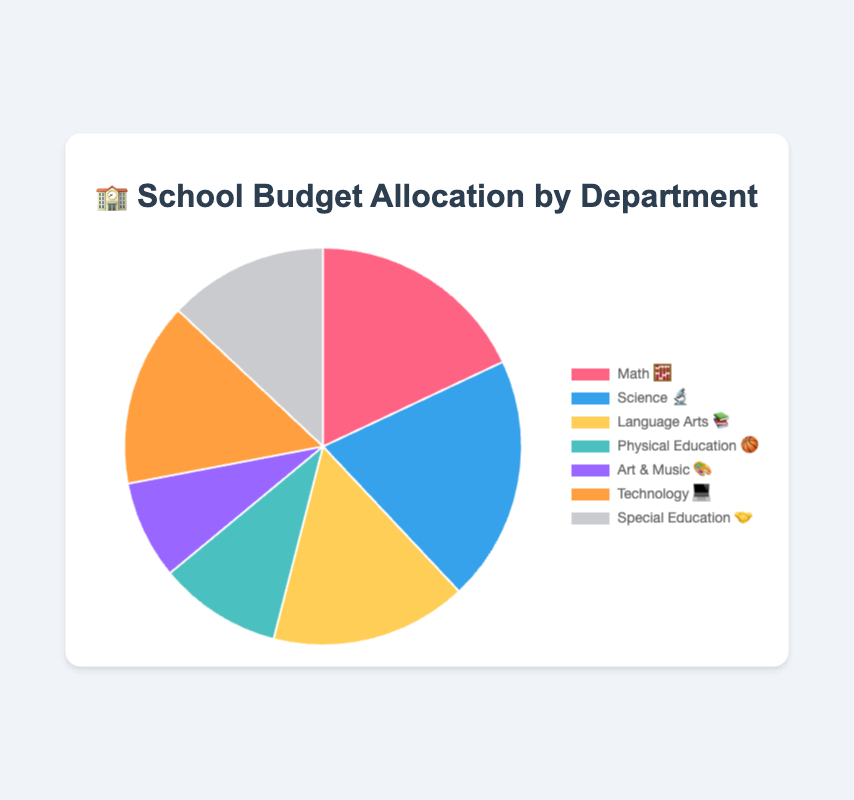What department has the largest budget allocation? The department with the highest budget percentage is the largest allocation. In the given data, Science (🔬) has the highest budget at 20%.
Answer: Science (🔬) What department has the smallest budget allocation? The department with the lowest budget percentage is the smallest allocation. In the given data, Art & Music (🎨) has the lowest budget at 8%.
Answer: Art & Music (🎨) How much more budget percentage does Science (🔬) get compared to Physical Education (🏀)? Subtract the budget percentage of Physical Education (10%) from that of Science (20%). The difference is 20% - 10% = 10%.
Answer: 10% What is the total budget percentage allocated to Math (🧮) and Technology (💻) combined? Add the budget percentages of Math (18%) and Technology (15%). The total is 18% + 15% = 33%.
Answer: 33% Which department has a budget contribution that is closest to the median budget allocation? First, sort the budget percentages: 8%, 10%, 13%, 15%, 16%, 18%, 20%. The median value is the fourth value in the sorted list, which is 15%, corresponding to Technology (💻).
Answer: Technology (💻) What is the difference in budget allocation between Language Arts (📚) and Special Education (🤝)? Subtract the budget percentage of Special Education (13%) from that of Language Arts (16%). The difference is 16% - 13% = 3%.
Answer: 3% How many departments have a budget allocation of 15% or higher? Identify the departments with budget percentages ≥ 15%. These are Math (18%), Science (20%), Language Arts (16%), and Technology (15%). There are 4 such departments.
Answer: 4 What is the average budget allocation across all departments? Add all budget percentages and divide by the total number of departments. The total sum is 18% + 20% + 16% + 10% + 8% + 15% + 13% = 100%. There are 7 departments, so the average is 100% / 7 ≈ 14.29%.
Answer: ~14.29% If the Technology (💻) budget was increased by 5%, how would this impact the budget compared to Science (🔬)? Adding 5% to Technology's budget increases it from 15% to 20%. This makes it equal to Science's budget, which is also at 20%.
Answer: Equal to Science (🔬) Which department has a budget just under 20%? Looking at the budget percentages, the department just under 20% is Math (18%).
Answer: Math (🧮) 